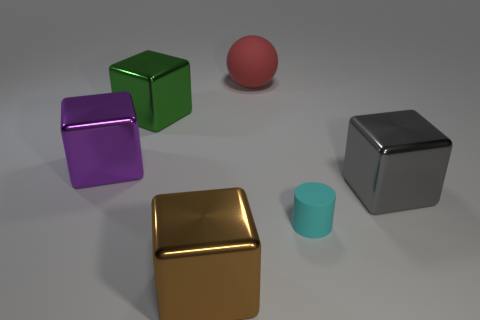The gray shiny thing that is the same size as the purple metal block is what shape? The gray object is a perfect example of a cube, characterized by its six square faces, all of which are congruent, meeting at right angles, and the same length on all edges. This shape exemplifies the principles of symmetry and uniformity. 